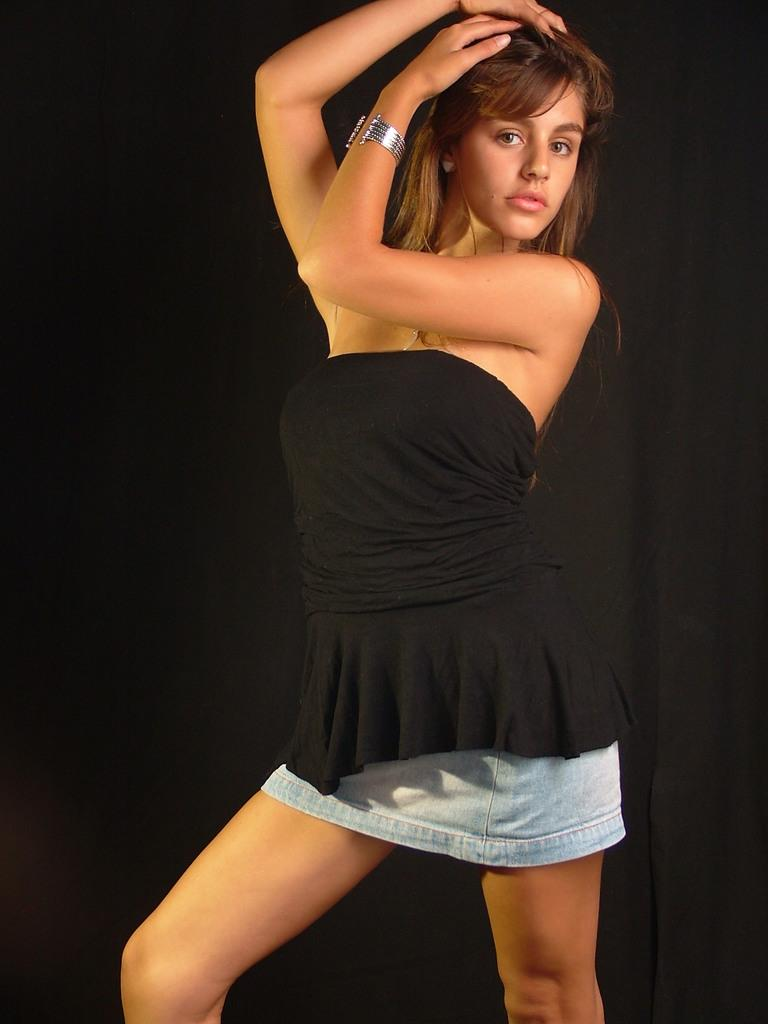Who is present in the image? There is a woman in the image. What is the woman doing in the image? The woman is watching and giving a pose. What can be seen in the background of the image? There is a black cloth in the background of the image. How does the woman stop the end of the cloth in the image? There is no cloth being held or manipulated by the woman in the image; the black cloth is in the background. 